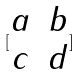Convert formula to latex. <formula><loc_0><loc_0><loc_500><loc_500>[ \begin{matrix} a & b \\ c & d \\ \end{matrix} ]</formula> 